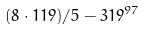Convert formula to latex. <formula><loc_0><loc_0><loc_500><loc_500>( 8 \cdot 1 1 9 ) / 5 - 3 1 9 ^ { 9 7 }</formula> 